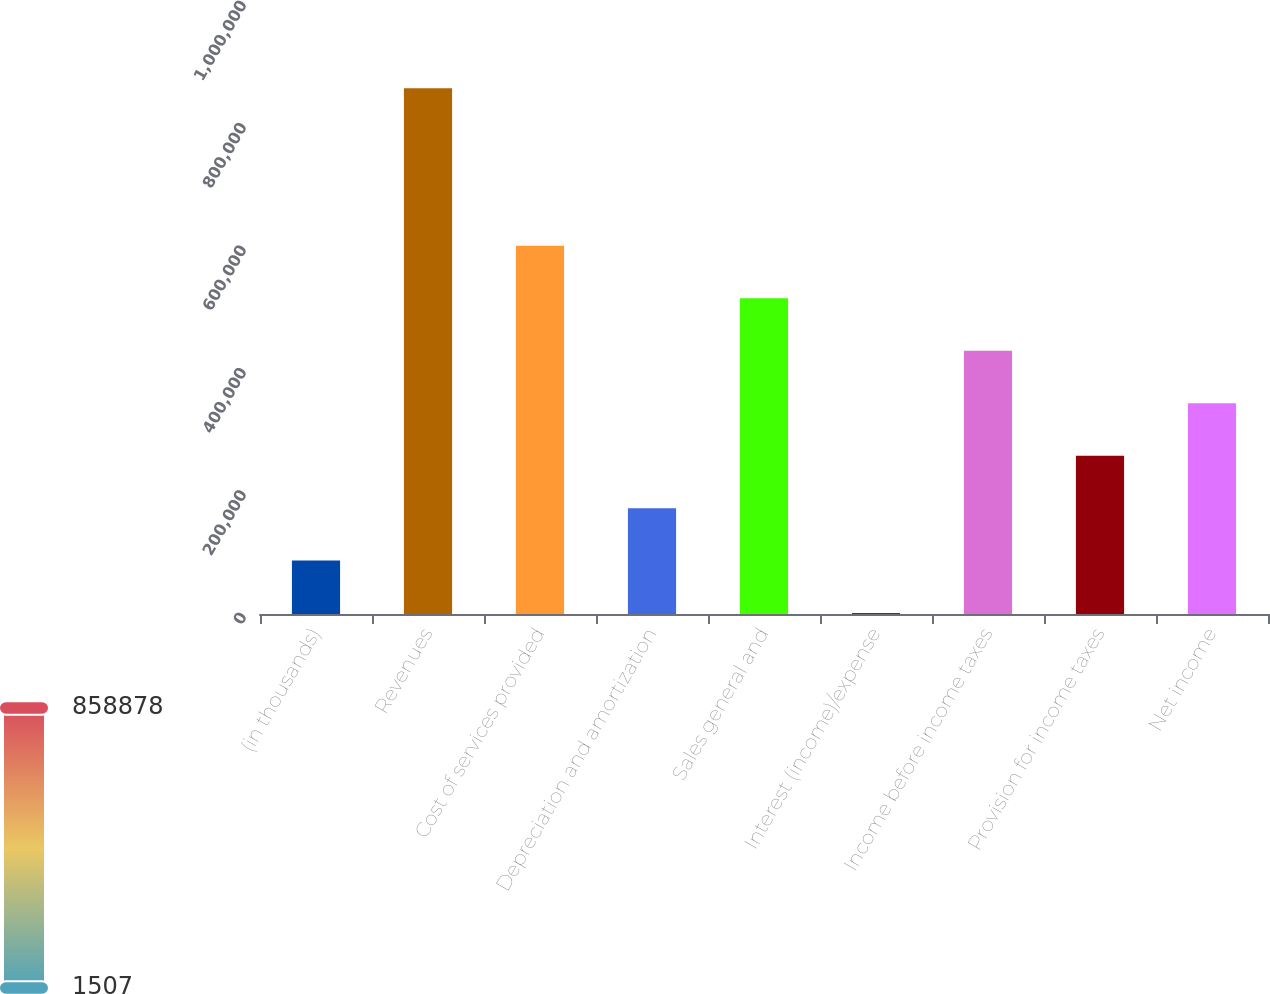Convert chart to OTSL. <chart><loc_0><loc_0><loc_500><loc_500><bar_chart><fcel>(in thousands)<fcel>Revenues<fcel>Cost of services provided<fcel>Depreciation and amortization<fcel>Sales general and<fcel>Interest (income)/expense<fcel>Income before income taxes<fcel>Provision for income taxes<fcel>Net income<nl><fcel>87244.1<fcel>858878<fcel>601667<fcel>172981<fcel>515930<fcel>1507<fcel>430192<fcel>258718<fcel>344455<nl></chart> 